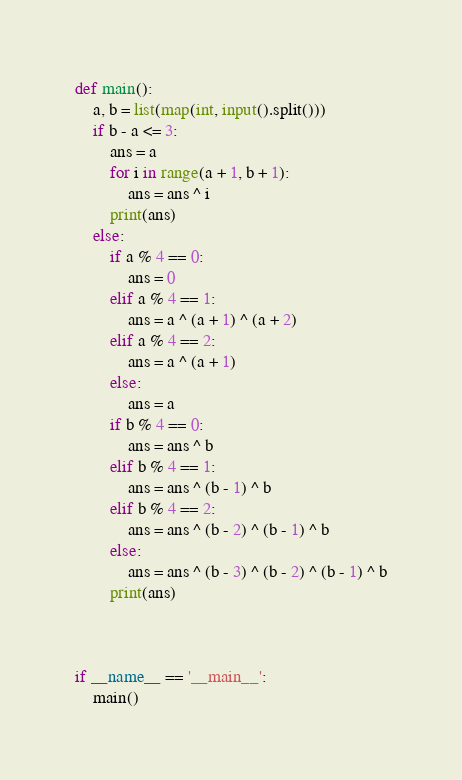<code> <loc_0><loc_0><loc_500><loc_500><_Python_>def main():
    a, b = list(map(int, input().split()))
    if b - a <= 3:
        ans = a
        for i in range(a + 1, b + 1):
            ans = ans ^ i
        print(ans)
    else:
        if a % 4 == 0:
            ans = 0
        elif a % 4 == 1:
            ans = a ^ (a + 1) ^ (a + 2)
        elif a % 4 == 2:
            ans = a ^ (a + 1)
        else:
            ans = a
        if b % 4 == 0:
            ans = ans ^ b
        elif b % 4 == 1:
            ans = ans ^ (b - 1) ^ b
        elif b % 4 == 2:
            ans = ans ^ (b - 2) ^ (b - 1) ^ b
        else:
            ans = ans ^ (b - 3) ^ (b - 2) ^ (b - 1) ^ b
        print(ans)



if __name__ == '__main__':
    main()
</code> 